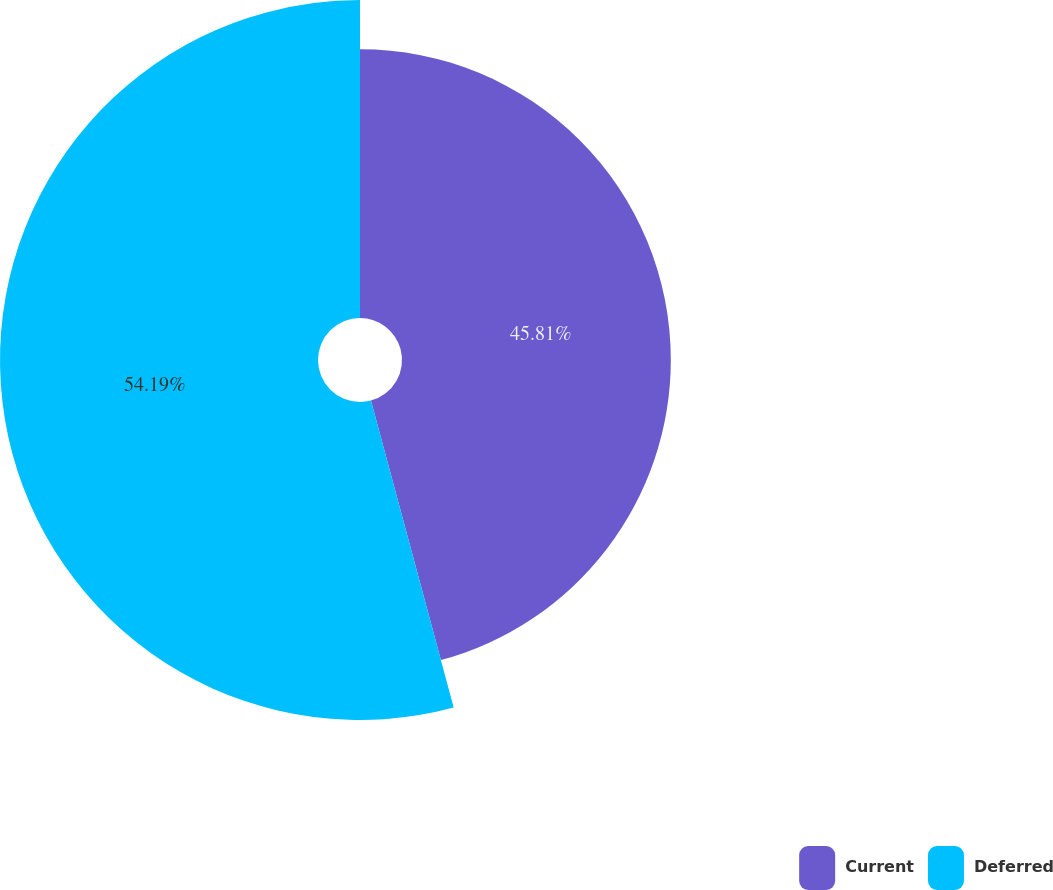Convert chart. <chart><loc_0><loc_0><loc_500><loc_500><pie_chart><fcel>Current<fcel>Deferred<nl><fcel>45.81%<fcel>54.19%<nl></chart> 